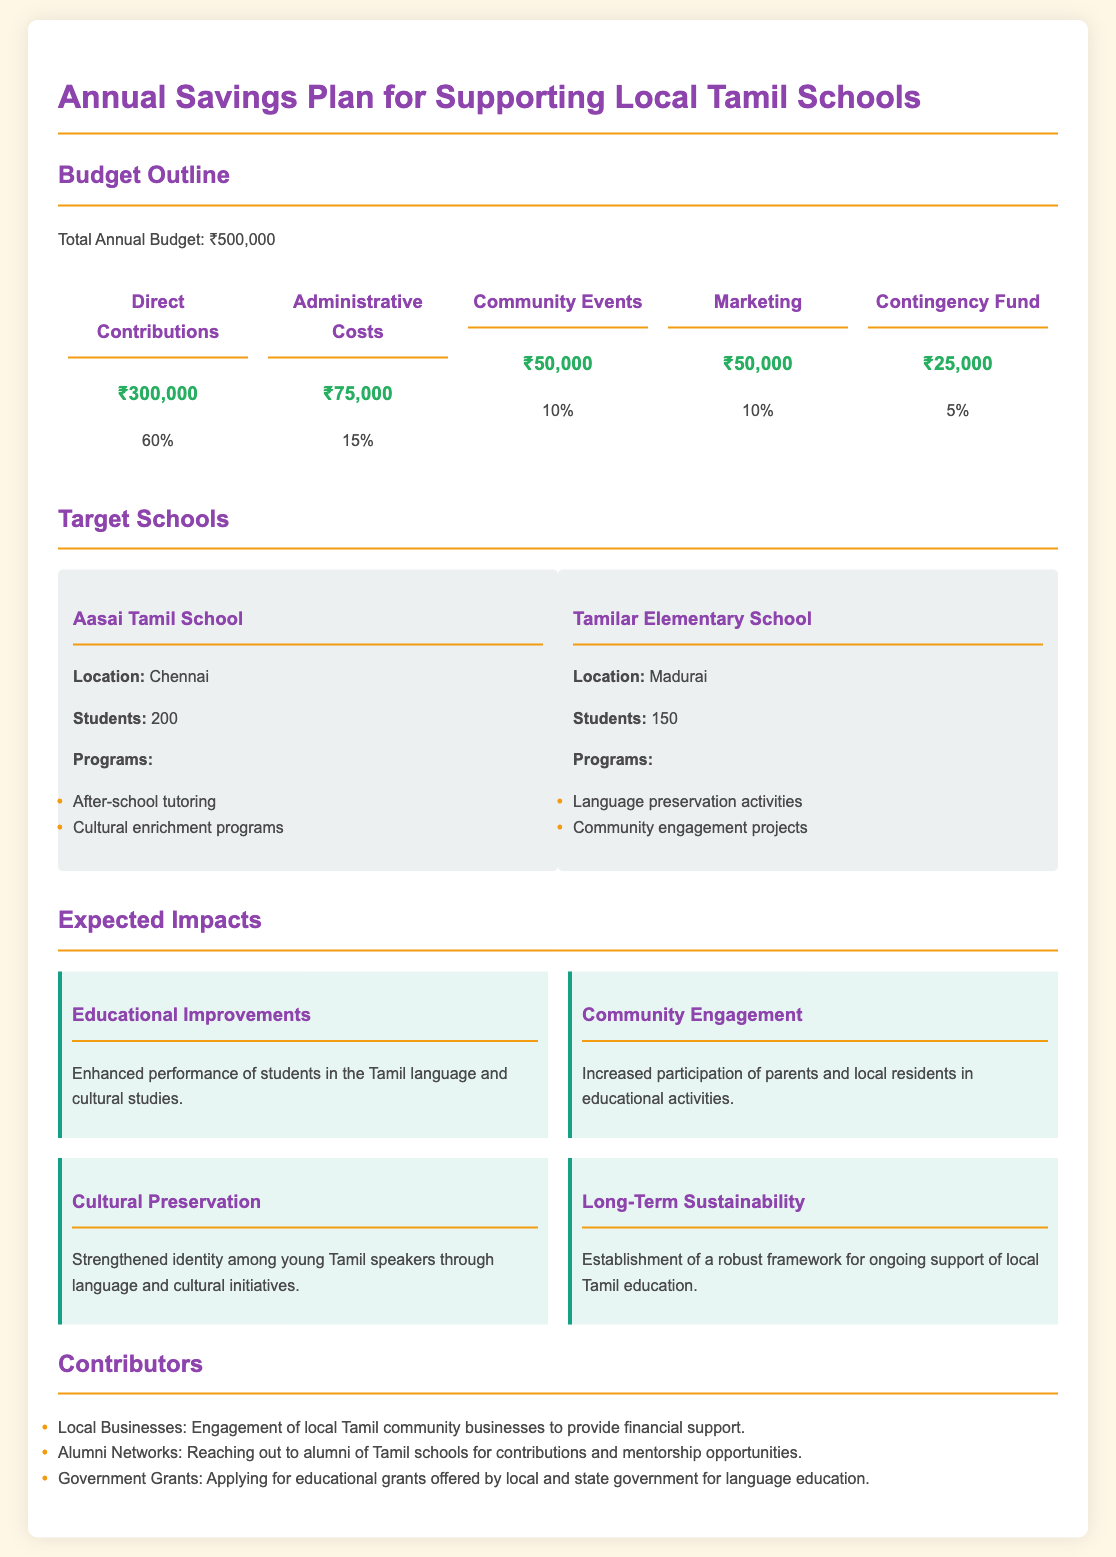What is the total annual budget? The total annual budget is clearly stated in the document.
Answer: ₹500,000 How much is allocated for direct contributions? The budget specifically lists the amount allocated for direct contributions.
Answer: ₹300,000 What percentage of the budget is reserved for administrative costs? The percentage of the budget for administrative costs is provided in the budget outline.
Answer: 15% Which school is located in Chennai? The document provides the names and locations of the target schools.
Answer: Aasai Tamil School What are the programs offered by Tamilar Elementary School? The document lists the educational programs associated with each school.
Answer: Language preservation activities, Community engagement projects What is one expected impact of the annual savings plan? The expected impacts of the savings plan are detailed in the impact section.
Answer: Enhanced performance of students in the Tamil language and cultural studies Who is one of the contributors mentioned in the document? The contributors section lists various supportive entities for the funding.
Answer: Local Businesses How many students attend Aasai Tamil School? The number of students at Aasai Tamil School is specified in the document.
Answer: 200 